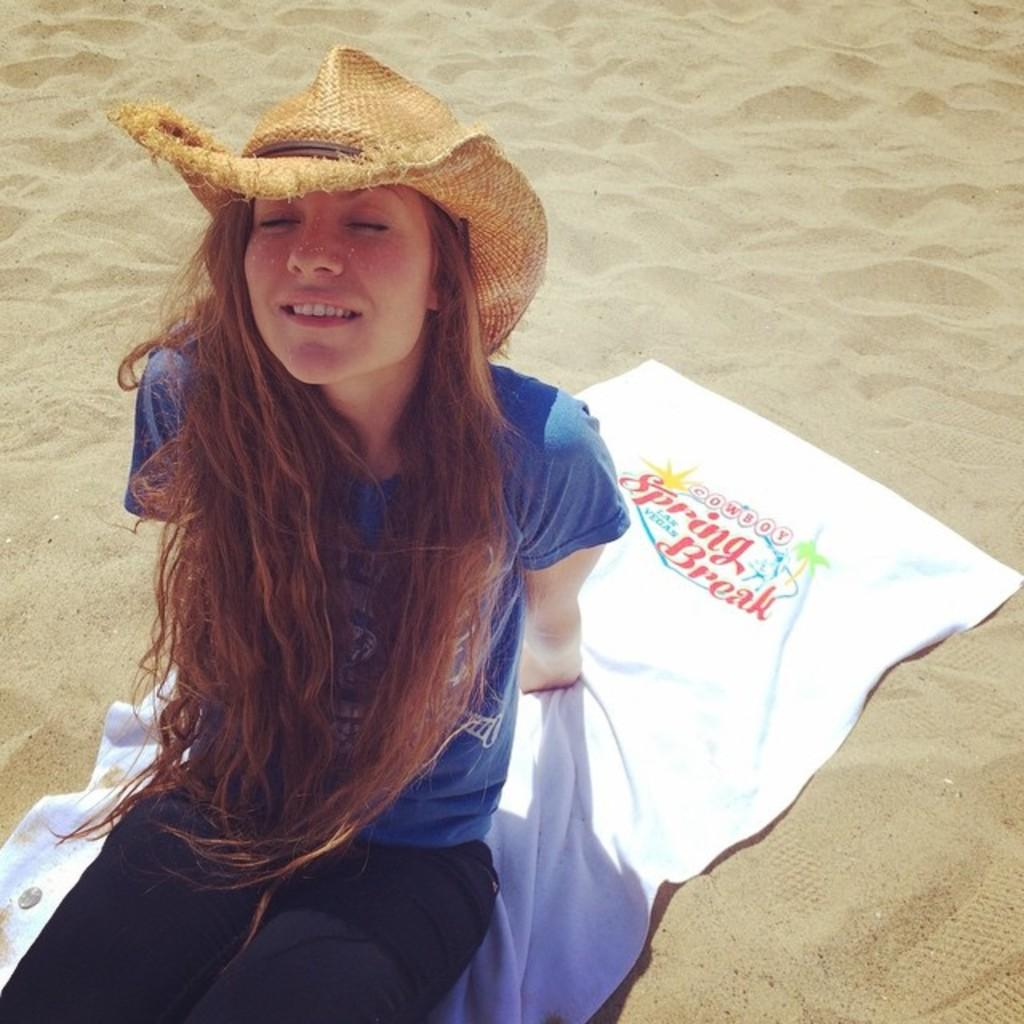Who is present in the image? There is a woman in the image. What is the woman wearing on her head? The woman is wearing a cap. What is the woman sitting on? The woman is seated on a towel. What type of surface can be seen in the image? There is sand visible in the image. What type of creature can be seen interacting with the woman in the image? There is no creature present in the image; it only features a woman seated on a towel. What sound can be heard coming from the woman in the image? The image is silent, so no sounds can be heard. 